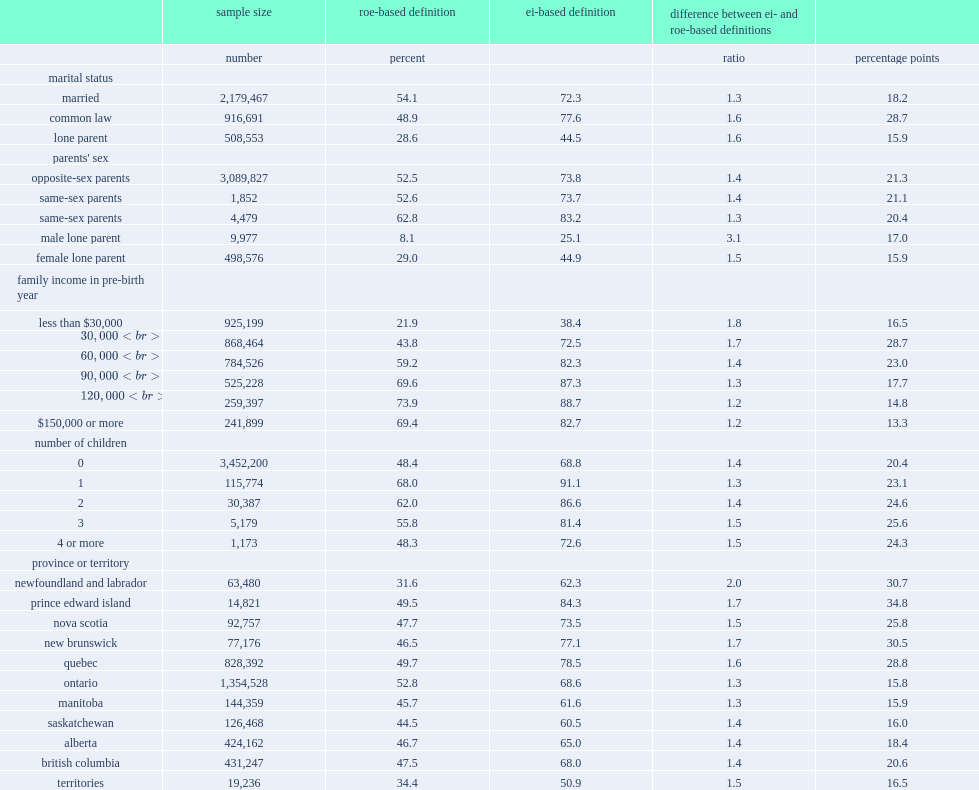By marital status,which kind of parents has the largest difference between the two definitions in absolute terms? Common law. By parents'sex,which kind of parents has the largest relative difference between the two definitions? Male lone parent. By parents'sex,which kind of parents has the largest absolute difference between the two definitions? Opposite-sex parents. By family income,which group has the largest absolute difference between the two definitions? $30,000 to $59,999. 